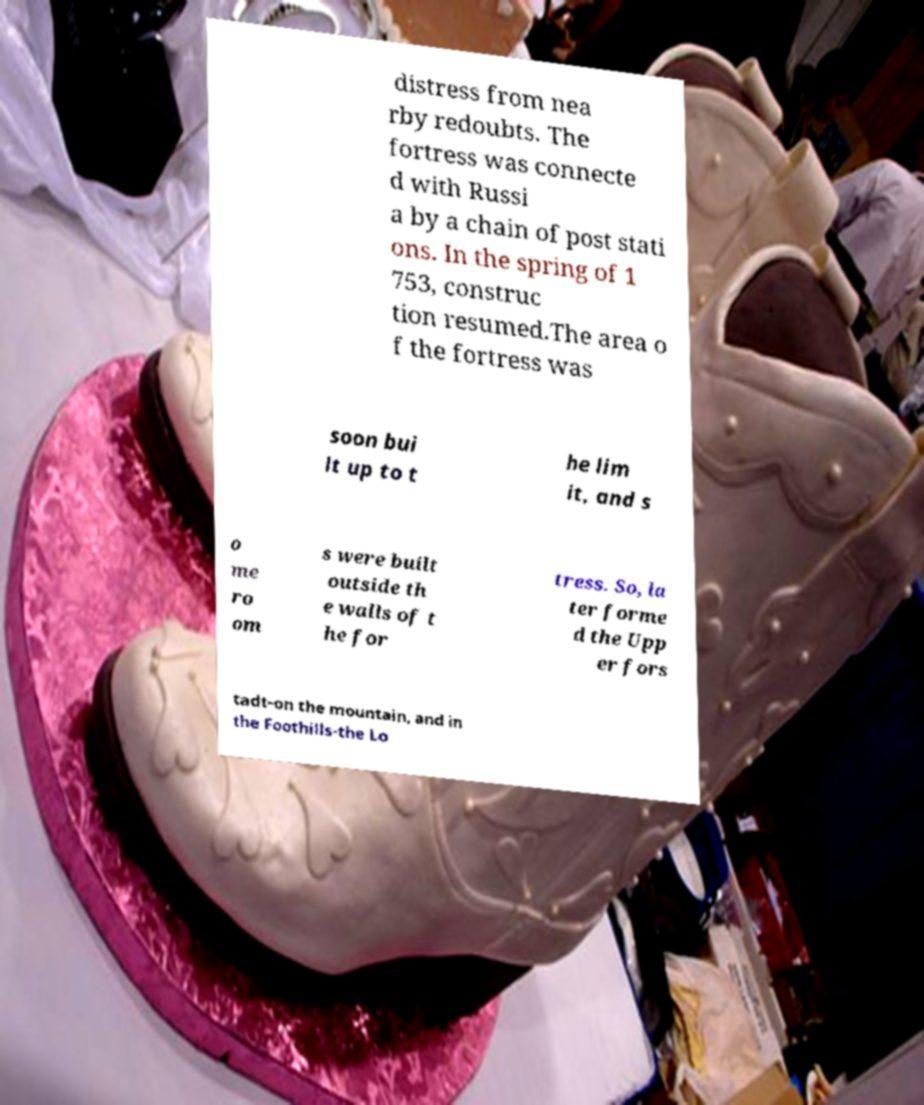Could you assist in decoding the text presented in this image and type it out clearly? distress from nea rby redoubts. The fortress was connecte d with Russi a by a chain of post stati ons. In the spring of 1 753, construc tion resumed.The area o f the fortress was soon bui lt up to t he lim it, and s o me ro om s were built outside th e walls of t he for tress. So, la ter forme d the Upp er fors tadt-on the mountain, and in the Foothills-the Lo 